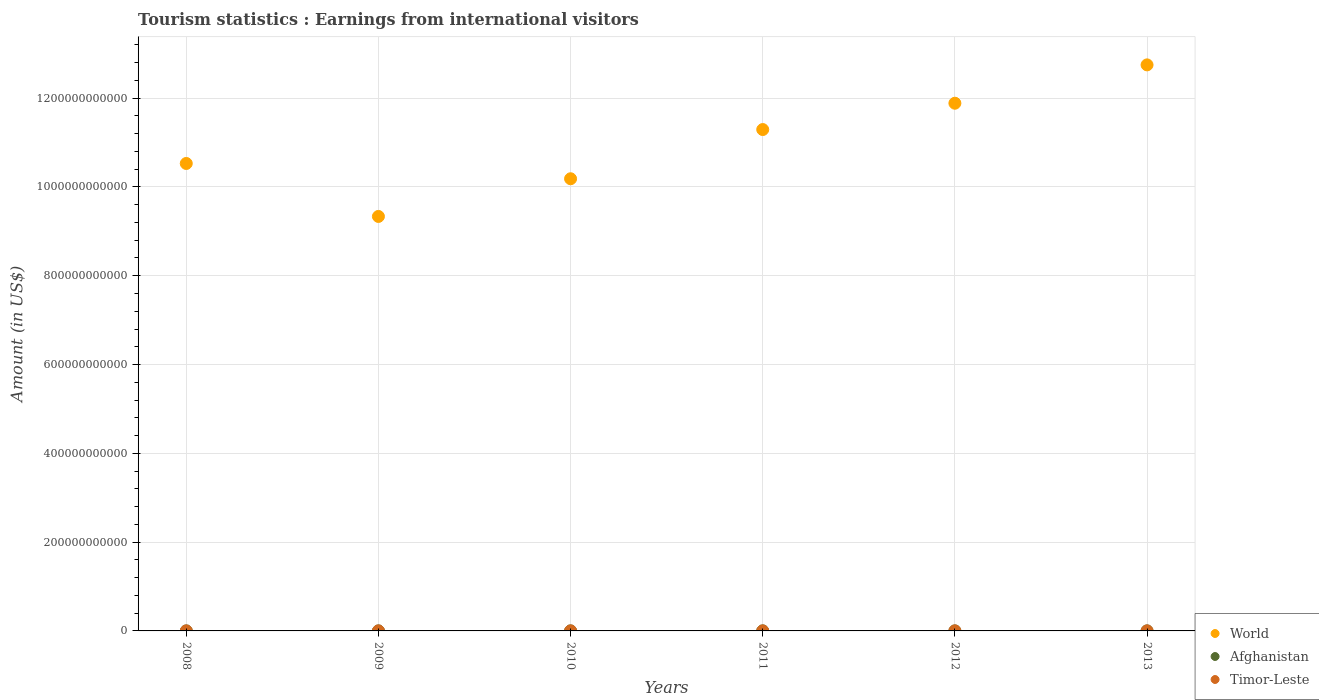How many different coloured dotlines are there?
Provide a short and direct response. 3. Is the number of dotlines equal to the number of legend labels?
Keep it short and to the point. Yes. What is the earnings from international visitors in World in 2009?
Ensure brevity in your answer.  9.34e+11. Across all years, what is the maximum earnings from international visitors in Afghanistan?
Your answer should be compact. 1.27e+08. Across all years, what is the minimum earnings from international visitors in Afghanistan?
Offer a terse response. 5.80e+07. In which year was the earnings from international visitors in World minimum?
Provide a short and direct response. 2009. What is the total earnings from international visitors in Timor-Leste in the graph?
Provide a succinct answer. 3.99e+08. What is the difference between the earnings from international visitors in World in 2008 and that in 2009?
Offer a very short reply. 1.19e+11. What is the difference between the earnings from international visitors in Afghanistan in 2011 and the earnings from international visitors in Timor-Leste in 2013?
Give a very brief answer. 7.00e+07. What is the average earnings from international visitors in World per year?
Keep it short and to the point. 1.10e+12. In the year 2009, what is the difference between the earnings from international visitors in World and earnings from international visitors in Timor-Leste?
Keep it short and to the point. 9.33e+11. What is the ratio of the earnings from international visitors in World in 2011 to that in 2012?
Your answer should be compact. 0.95. Is the earnings from international visitors in Timor-Leste in 2008 less than that in 2013?
Your answer should be compact. Yes. What is the difference between the highest and the second highest earnings from international visitors in Timor-Leste?
Provide a short and direct response. 2.30e+07. What is the difference between the highest and the lowest earnings from international visitors in Timor-Leste?
Provide a succinct answer. 4.10e+07. In how many years, is the earnings from international visitors in World greater than the average earnings from international visitors in World taken over all years?
Your answer should be compact. 3. Is the sum of the earnings from international visitors in World in 2009 and 2013 greater than the maximum earnings from international visitors in Timor-Leste across all years?
Offer a terse response. Yes. Is the earnings from international visitors in Timor-Leste strictly greater than the earnings from international visitors in Afghanistan over the years?
Give a very brief answer. No. How many years are there in the graph?
Offer a terse response. 6. What is the difference between two consecutive major ticks on the Y-axis?
Offer a very short reply. 2.00e+11. Does the graph contain any zero values?
Offer a very short reply. No. How many legend labels are there?
Ensure brevity in your answer.  3. How are the legend labels stacked?
Ensure brevity in your answer.  Vertical. What is the title of the graph?
Your answer should be very brief. Tourism statistics : Earnings from international visitors. Does "Maldives" appear as one of the legend labels in the graph?
Your answer should be very brief. No. What is the label or title of the Y-axis?
Your response must be concise. Amount (in US$). What is the Amount (in US$) of World in 2008?
Ensure brevity in your answer.  1.05e+12. What is the Amount (in US$) in Afghanistan in 2008?
Make the answer very short. 5.80e+07. What is the Amount (in US$) in Timor-Leste in 2008?
Keep it short and to the point. 5.10e+07. What is the Amount (in US$) in World in 2009?
Provide a succinct answer. 9.34e+11. What is the Amount (in US$) in Afghanistan in 2009?
Your answer should be very brief. 6.10e+07. What is the Amount (in US$) of Timor-Leste in 2009?
Provide a succinct answer. 6.90e+07. What is the Amount (in US$) in World in 2010?
Make the answer very short. 1.02e+12. What is the Amount (in US$) in Afghanistan in 2010?
Your answer should be compact. 8.60e+07. What is the Amount (in US$) of Timor-Leste in 2010?
Give a very brief answer. 6.80e+07. What is the Amount (in US$) of World in 2011?
Your answer should be very brief. 1.13e+12. What is the Amount (in US$) of Afghanistan in 2011?
Your answer should be very brief. 1.27e+08. What is the Amount (in US$) of Timor-Leste in 2011?
Your answer should be compact. 6.20e+07. What is the Amount (in US$) of World in 2012?
Provide a short and direct response. 1.19e+12. What is the Amount (in US$) in Afghanistan in 2012?
Give a very brief answer. 8.00e+07. What is the Amount (in US$) in Timor-Leste in 2012?
Your answer should be compact. 9.20e+07. What is the Amount (in US$) of World in 2013?
Keep it short and to the point. 1.27e+12. What is the Amount (in US$) in Afghanistan in 2013?
Give a very brief answer. 1.00e+08. What is the Amount (in US$) of Timor-Leste in 2013?
Ensure brevity in your answer.  5.70e+07. Across all years, what is the maximum Amount (in US$) of World?
Your response must be concise. 1.27e+12. Across all years, what is the maximum Amount (in US$) in Afghanistan?
Ensure brevity in your answer.  1.27e+08. Across all years, what is the maximum Amount (in US$) of Timor-Leste?
Ensure brevity in your answer.  9.20e+07. Across all years, what is the minimum Amount (in US$) of World?
Offer a terse response. 9.34e+11. Across all years, what is the minimum Amount (in US$) of Afghanistan?
Provide a short and direct response. 5.80e+07. Across all years, what is the minimum Amount (in US$) of Timor-Leste?
Give a very brief answer. 5.10e+07. What is the total Amount (in US$) in World in the graph?
Provide a short and direct response. 6.60e+12. What is the total Amount (in US$) of Afghanistan in the graph?
Give a very brief answer. 5.12e+08. What is the total Amount (in US$) in Timor-Leste in the graph?
Give a very brief answer. 3.99e+08. What is the difference between the Amount (in US$) in World in 2008 and that in 2009?
Your answer should be very brief. 1.19e+11. What is the difference between the Amount (in US$) in Timor-Leste in 2008 and that in 2009?
Offer a very short reply. -1.80e+07. What is the difference between the Amount (in US$) of World in 2008 and that in 2010?
Make the answer very short. 3.44e+1. What is the difference between the Amount (in US$) of Afghanistan in 2008 and that in 2010?
Keep it short and to the point. -2.80e+07. What is the difference between the Amount (in US$) in Timor-Leste in 2008 and that in 2010?
Your response must be concise. -1.70e+07. What is the difference between the Amount (in US$) in World in 2008 and that in 2011?
Offer a very short reply. -7.64e+1. What is the difference between the Amount (in US$) in Afghanistan in 2008 and that in 2011?
Offer a terse response. -6.90e+07. What is the difference between the Amount (in US$) in Timor-Leste in 2008 and that in 2011?
Offer a terse response. -1.10e+07. What is the difference between the Amount (in US$) in World in 2008 and that in 2012?
Your answer should be compact. -1.36e+11. What is the difference between the Amount (in US$) of Afghanistan in 2008 and that in 2012?
Keep it short and to the point. -2.20e+07. What is the difference between the Amount (in US$) in Timor-Leste in 2008 and that in 2012?
Your answer should be compact. -4.10e+07. What is the difference between the Amount (in US$) of World in 2008 and that in 2013?
Offer a very short reply. -2.22e+11. What is the difference between the Amount (in US$) of Afghanistan in 2008 and that in 2013?
Make the answer very short. -4.20e+07. What is the difference between the Amount (in US$) in Timor-Leste in 2008 and that in 2013?
Provide a short and direct response. -6.00e+06. What is the difference between the Amount (in US$) of World in 2009 and that in 2010?
Your answer should be compact. -8.49e+1. What is the difference between the Amount (in US$) in Afghanistan in 2009 and that in 2010?
Provide a short and direct response. -2.50e+07. What is the difference between the Amount (in US$) in Timor-Leste in 2009 and that in 2010?
Your response must be concise. 1.00e+06. What is the difference between the Amount (in US$) in World in 2009 and that in 2011?
Your answer should be very brief. -1.96e+11. What is the difference between the Amount (in US$) of Afghanistan in 2009 and that in 2011?
Your answer should be compact. -6.60e+07. What is the difference between the Amount (in US$) of Timor-Leste in 2009 and that in 2011?
Ensure brevity in your answer.  7.00e+06. What is the difference between the Amount (in US$) of World in 2009 and that in 2012?
Keep it short and to the point. -2.55e+11. What is the difference between the Amount (in US$) in Afghanistan in 2009 and that in 2012?
Offer a very short reply. -1.90e+07. What is the difference between the Amount (in US$) of Timor-Leste in 2009 and that in 2012?
Your answer should be compact. -2.30e+07. What is the difference between the Amount (in US$) in World in 2009 and that in 2013?
Make the answer very short. -3.41e+11. What is the difference between the Amount (in US$) in Afghanistan in 2009 and that in 2013?
Your answer should be compact. -3.90e+07. What is the difference between the Amount (in US$) in Timor-Leste in 2009 and that in 2013?
Keep it short and to the point. 1.20e+07. What is the difference between the Amount (in US$) of World in 2010 and that in 2011?
Give a very brief answer. -1.11e+11. What is the difference between the Amount (in US$) in Afghanistan in 2010 and that in 2011?
Your answer should be compact. -4.10e+07. What is the difference between the Amount (in US$) of Timor-Leste in 2010 and that in 2011?
Ensure brevity in your answer.  6.00e+06. What is the difference between the Amount (in US$) of World in 2010 and that in 2012?
Your response must be concise. -1.70e+11. What is the difference between the Amount (in US$) in Afghanistan in 2010 and that in 2012?
Your answer should be very brief. 6.00e+06. What is the difference between the Amount (in US$) in Timor-Leste in 2010 and that in 2012?
Provide a succinct answer. -2.40e+07. What is the difference between the Amount (in US$) in World in 2010 and that in 2013?
Offer a very short reply. -2.57e+11. What is the difference between the Amount (in US$) in Afghanistan in 2010 and that in 2013?
Make the answer very short. -1.40e+07. What is the difference between the Amount (in US$) of Timor-Leste in 2010 and that in 2013?
Provide a succinct answer. 1.10e+07. What is the difference between the Amount (in US$) of World in 2011 and that in 2012?
Offer a terse response. -5.93e+1. What is the difference between the Amount (in US$) of Afghanistan in 2011 and that in 2012?
Your answer should be very brief. 4.70e+07. What is the difference between the Amount (in US$) of Timor-Leste in 2011 and that in 2012?
Offer a terse response. -3.00e+07. What is the difference between the Amount (in US$) in World in 2011 and that in 2013?
Give a very brief answer. -1.46e+11. What is the difference between the Amount (in US$) in Afghanistan in 2011 and that in 2013?
Give a very brief answer. 2.70e+07. What is the difference between the Amount (in US$) of Timor-Leste in 2011 and that in 2013?
Offer a terse response. 5.00e+06. What is the difference between the Amount (in US$) of World in 2012 and that in 2013?
Offer a very short reply. -8.64e+1. What is the difference between the Amount (in US$) of Afghanistan in 2012 and that in 2013?
Provide a short and direct response. -2.00e+07. What is the difference between the Amount (in US$) in Timor-Leste in 2012 and that in 2013?
Give a very brief answer. 3.50e+07. What is the difference between the Amount (in US$) of World in 2008 and the Amount (in US$) of Afghanistan in 2009?
Your response must be concise. 1.05e+12. What is the difference between the Amount (in US$) of World in 2008 and the Amount (in US$) of Timor-Leste in 2009?
Your answer should be compact. 1.05e+12. What is the difference between the Amount (in US$) in Afghanistan in 2008 and the Amount (in US$) in Timor-Leste in 2009?
Offer a terse response. -1.10e+07. What is the difference between the Amount (in US$) in World in 2008 and the Amount (in US$) in Afghanistan in 2010?
Ensure brevity in your answer.  1.05e+12. What is the difference between the Amount (in US$) of World in 2008 and the Amount (in US$) of Timor-Leste in 2010?
Your response must be concise. 1.05e+12. What is the difference between the Amount (in US$) of Afghanistan in 2008 and the Amount (in US$) of Timor-Leste in 2010?
Provide a succinct answer. -1.00e+07. What is the difference between the Amount (in US$) of World in 2008 and the Amount (in US$) of Afghanistan in 2011?
Provide a short and direct response. 1.05e+12. What is the difference between the Amount (in US$) of World in 2008 and the Amount (in US$) of Timor-Leste in 2011?
Give a very brief answer. 1.05e+12. What is the difference between the Amount (in US$) in World in 2008 and the Amount (in US$) in Afghanistan in 2012?
Offer a very short reply. 1.05e+12. What is the difference between the Amount (in US$) in World in 2008 and the Amount (in US$) in Timor-Leste in 2012?
Provide a short and direct response. 1.05e+12. What is the difference between the Amount (in US$) of Afghanistan in 2008 and the Amount (in US$) of Timor-Leste in 2012?
Keep it short and to the point. -3.40e+07. What is the difference between the Amount (in US$) of World in 2008 and the Amount (in US$) of Afghanistan in 2013?
Ensure brevity in your answer.  1.05e+12. What is the difference between the Amount (in US$) of World in 2008 and the Amount (in US$) of Timor-Leste in 2013?
Offer a very short reply. 1.05e+12. What is the difference between the Amount (in US$) in Afghanistan in 2008 and the Amount (in US$) in Timor-Leste in 2013?
Provide a short and direct response. 1.00e+06. What is the difference between the Amount (in US$) of World in 2009 and the Amount (in US$) of Afghanistan in 2010?
Offer a terse response. 9.33e+11. What is the difference between the Amount (in US$) of World in 2009 and the Amount (in US$) of Timor-Leste in 2010?
Make the answer very short. 9.33e+11. What is the difference between the Amount (in US$) in Afghanistan in 2009 and the Amount (in US$) in Timor-Leste in 2010?
Keep it short and to the point. -7.00e+06. What is the difference between the Amount (in US$) in World in 2009 and the Amount (in US$) in Afghanistan in 2011?
Your response must be concise. 9.33e+11. What is the difference between the Amount (in US$) of World in 2009 and the Amount (in US$) of Timor-Leste in 2011?
Provide a succinct answer. 9.33e+11. What is the difference between the Amount (in US$) of World in 2009 and the Amount (in US$) of Afghanistan in 2012?
Ensure brevity in your answer.  9.33e+11. What is the difference between the Amount (in US$) of World in 2009 and the Amount (in US$) of Timor-Leste in 2012?
Keep it short and to the point. 9.33e+11. What is the difference between the Amount (in US$) of Afghanistan in 2009 and the Amount (in US$) of Timor-Leste in 2012?
Ensure brevity in your answer.  -3.10e+07. What is the difference between the Amount (in US$) in World in 2009 and the Amount (in US$) in Afghanistan in 2013?
Your answer should be compact. 9.33e+11. What is the difference between the Amount (in US$) of World in 2009 and the Amount (in US$) of Timor-Leste in 2013?
Give a very brief answer. 9.34e+11. What is the difference between the Amount (in US$) of Afghanistan in 2009 and the Amount (in US$) of Timor-Leste in 2013?
Your response must be concise. 4.00e+06. What is the difference between the Amount (in US$) in World in 2010 and the Amount (in US$) in Afghanistan in 2011?
Offer a very short reply. 1.02e+12. What is the difference between the Amount (in US$) in World in 2010 and the Amount (in US$) in Timor-Leste in 2011?
Offer a terse response. 1.02e+12. What is the difference between the Amount (in US$) in Afghanistan in 2010 and the Amount (in US$) in Timor-Leste in 2011?
Provide a short and direct response. 2.40e+07. What is the difference between the Amount (in US$) in World in 2010 and the Amount (in US$) in Afghanistan in 2012?
Make the answer very short. 1.02e+12. What is the difference between the Amount (in US$) in World in 2010 and the Amount (in US$) in Timor-Leste in 2012?
Your response must be concise. 1.02e+12. What is the difference between the Amount (in US$) in Afghanistan in 2010 and the Amount (in US$) in Timor-Leste in 2012?
Your response must be concise. -6.00e+06. What is the difference between the Amount (in US$) of World in 2010 and the Amount (in US$) of Afghanistan in 2013?
Make the answer very short. 1.02e+12. What is the difference between the Amount (in US$) in World in 2010 and the Amount (in US$) in Timor-Leste in 2013?
Offer a terse response. 1.02e+12. What is the difference between the Amount (in US$) of Afghanistan in 2010 and the Amount (in US$) of Timor-Leste in 2013?
Keep it short and to the point. 2.90e+07. What is the difference between the Amount (in US$) of World in 2011 and the Amount (in US$) of Afghanistan in 2012?
Offer a very short reply. 1.13e+12. What is the difference between the Amount (in US$) in World in 2011 and the Amount (in US$) in Timor-Leste in 2012?
Ensure brevity in your answer.  1.13e+12. What is the difference between the Amount (in US$) of Afghanistan in 2011 and the Amount (in US$) of Timor-Leste in 2012?
Provide a short and direct response. 3.50e+07. What is the difference between the Amount (in US$) in World in 2011 and the Amount (in US$) in Afghanistan in 2013?
Provide a short and direct response. 1.13e+12. What is the difference between the Amount (in US$) of World in 2011 and the Amount (in US$) of Timor-Leste in 2013?
Offer a terse response. 1.13e+12. What is the difference between the Amount (in US$) in Afghanistan in 2011 and the Amount (in US$) in Timor-Leste in 2013?
Provide a succinct answer. 7.00e+07. What is the difference between the Amount (in US$) of World in 2012 and the Amount (in US$) of Afghanistan in 2013?
Give a very brief answer. 1.19e+12. What is the difference between the Amount (in US$) in World in 2012 and the Amount (in US$) in Timor-Leste in 2013?
Ensure brevity in your answer.  1.19e+12. What is the difference between the Amount (in US$) in Afghanistan in 2012 and the Amount (in US$) in Timor-Leste in 2013?
Provide a succinct answer. 2.30e+07. What is the average Amount (in US$) of World per year?
Offer a terse response. 1.10e+12. What is the average Amount (in US$) of Afghanistan per year?
Your answer should be very brief. 8.53e+07. What is the average Amount (in US$) in Timor-Leste per year?
Keep it short and to the point. 6.65e+07. In the year 2008, what is the difference between the Amount (in US$) in World and Amount (in US$) in Afghanistan?
Your answer should be compact. 1.05e+12. In the year 2008, what is the difference between the Amount (in US$) of World and Amount (in US$) of Timor-Leste?
Your answer should be compact. 1.05e+12. In the year 2009, what is the difference between the Amount (in US$) of World and Amount (in US$) of Afghanistan?
Offer a terse response. 9.33e+11. In the year 2009, what is the difference between the Amount (in US$) in World and Amount (in US$) in Timor-Leste?
Your response must be concise. 9.33e+11. In the year 2009, what is the difference between the Amount (in US$) in Afghanistan and Amount (in US$) in Timor-Leste?
Your response must be concise. -8.00e+06. In the year 2010, what is the difference between the Amount (in US$) of World and Amount (in US$) of Afghanistan?
Your answer should be compact. 1.02e+12. In the year 2010, what is the difference between the Amount (in US$) in World and Amount (in US$) in Timor-Leste?
Provide a succinct answer. 1.02e+12. In the year 2010, what is the difference between the Amount (in US$) of Afghanistan and Amount (in US$) of Timor-Leste?
Offer a very short reply. 1.80e+07. In the year 2011, what is the difference between the Amount (in US$) in World and Amount (in US$) in Afghanistan?
Offer a very short reply. 1.13e+12. In the year 2011, what is the difference between the Amount (in US$) in World and Amount (in US$) in Timor-Leste?
Give a very brief answer. 1.13e+12. In the year 2011, what is the difference between the Amount (in US$) in Afghanistan and Amount (in US$) in Timor-Leste?
Your answer should be very brief. 6.50e+07. In the year 2012, what is the difference between the Amount (in US$) in World and Amount (in US$) in Afghanistan?
Offer a terse response. 1.19e+12. In the year 2012, what is the difference between the Amount (in US$) in World and Amount (in US$) in Timor-Leste?
Provide a short and direct response. 1.19e+12. In the year 2012, what is the difference between the Amount (in US$) of Afghanistan and Amount (in US$) of Timor-Leste?
Provide a succinct answer. -1.20e+07. In the year 2013, what is the difference between the Amount (in US$) of World and Amount (in US$) of Afghanistan?
Ensure brevity in your answer.  1.27e+12. In the year 2013, what is the difference between the Amount (in US$) in World and Amount (in US$) in Timor-Leste?
Your answer should be very brief. 1.27e+12. In the year 2013, what is the difference between the Amount (in US$) of Afghanistan and Amount (in US$) of Timor-Leste?
Provide a succinct answer. 4.30e+07. What is the ratio of the Amount (in US$) of World in 2008 to that in 2009?
Keep it short and to the point. 1.13. What is the ratio of the Amount (in US$) in Afghanistan in 2008 to that in 2009?
Ensure brevity in your answer.  0.95. What is the ratio of the Amount (in US$) of Timor-Leste in 2008 to that in 2009?
Your answer should be very brief. 0.74. What is the ratio of the Amount (in US$) in World in 2008 to that in 2010?
Offer a very short reply. 1.03. What is the ratio of the Amount (in US$) in Afghanistan in 2008 to that in 2010?
Your answer should be very brief. 0.67. What is the ratio of the Amount (in US$) in World in 2008 to that in 2011?
Provide a short and direct response. 0.93. What is the ratio of the Amount (in US$) in Afghanistan in 2008 to that in 2011?
Make the answer very short. 0.46. What is the ratio of the Amount (in US$) in Timor-Leste in 2008 to that in 2011?
Make the answer very short. 0.82. What is the ratio of the Amount (in US$) in World in 2008 to that in 2012?
Your answer should be very brief. 0.89. What is the ratio of the Amount (in US$) in Afghanistan in 2008 to that in 2012?
Ensure brevity in your answer.  0.72. What is the ratio of the Amount (in US$) in Timor-Leste in 2008 to that in 2012?
Your answer should be very brief. 0.55. What is the ratio of the Amount (in US$) in World in 2008 to that in 2013?
Give a very brief answer. 0.83. What is the ratio of the Amount (in US$) of Afghanistan in 2008 to that in 2013?
Offer a very short reply. 0.58. What is the ratio of the Amount (in US$) of Timor-Leste in 2008 to that in 2013?
Provide a succinct answer. 0.89. What is the ratio of the Amount (in US$) of Afghanistan in 2009 to that in 2010?
Make the answer very short. 0.71. What is the ratio of the Amount (in US$) of Timor-Leste in 2009 to that in 2010?
Make the answer very short. 1.01. What is the ratio of the Amount (in US$) in World in 2009 to that in 2011?
Offer a very short reply. 0.83. What is the ratio of the Amount (in US$) in Afghanistan in 2009 to that in 2011?
Your response must be concise. 0.48. What is the ratio of the Amount (in US$) of Timor-Leste in 2009 to that in 2011?
Keep it short and to the point. 1.11. What is the ratio of the Amount (in US$) in World in 2009 to that in 2012?
Offer a very short reply. 0.79. What is the ratio of the Amount (in US$) in Afghanistan in 2009 to that in 2012?
Provide a short and direct response. 0.76. What is the ratio of the Amount (in US$) of Timor-Leste in 2009 to that in 2012?
Offer a terse response. 0.75. What is the ratio of the Amount (in US$) of World in 2009 to that in 2013?
Ensure brevity in your answer.  0.73. What is the ratio of the Amount (in US$) in Afghanistan in 2009 to that in 2013?
Keep it short and to the point. 0.61. What is the ratio of the Amount (in US$) of Timor-Leste in 2009 to that in 2013?
Offer a terse response. 1.21. What is the ratio of the Amount (in US$) in World in 2010 to that in 2011?
Ensure brevity in your answer.  0.9. What is the ratio of the Amount (in US$) of Afghanistan in 2010 to that in 2011?
Provide a short and direct response. 0.68. What is the ratio of the Amount (in US$) of Timor-Leste in 2010 to that in 2011?
Offer a very short reply. 1.1. What is the ratio of the Amount (in US$) of World in 2010 to that in 2012?
Your answer should be very brief. 0.86. What is the ratio of the Amount (in US$) of Afghanistan in 2010 to that in 2012?
Give a very brief answer. 1.07. What is the ratio of the Amount (in US$) in Timor-Leste in 2010 to that in 2012?
Your answer should be compact. 0.74. What is the ratio of the Amount (in US$) of World in 2010 to that in 2013?
Make the answer very short. 0.8. What is the ratio of the Amount (in US$) in Afghanistan in 2010 to that in 2013?
Offer a very short reply. 0.86. What is the ratio of the Amount (in US$) of Timor-Leste in 2010 to that in 2013?
Provide a short and direct response. 1.19. What is the ratio of the Amount (in US$) of World in 2011 to that in 2012?
Your answer should be compact. 0.95. What is the ratio of the Amount (in US$) of Afghanistan in 2011 to that in 2012?
Keep it short and to the point. 1.59. What is the ratio of the Amount (in US$) in Timor-Leste in 2011 to that in 2012?
Your answer should be compact. 0.67. What is the ratio of the Amount (in US$) of World in 2011 to that in 2013?
Offer a terse response. 0.89. What is the ratio of the Amount (in US$) of Afghanistan in 2011 to that in 2013?
Your answer should be compact. 1.27. What is the ratio of the Amount (in US$) in Timor-Leste in 2011 to that in 2013?
Your response must be concise. 1.09. What is the ratio of the Amount (in US$) of World in 2012 to that in 2013?
Your answer should be very brief. 0.93. What is the ratio of the Amount (in US$) in Timor-Leste in 2012 to that in 2013?
Your answer should be very brief. 1.61. What is the difference between the highest and the second highest Amount (in US$) of World?
Provide a short and direct response. 8.64e+1. What is the difference between the highest and the second highest Amount (in US$) of Afghanistan?
Offer a terse response. 2.70e+07. What is the difference between the highest and the second highest Amount (in US$) in Timor-Leste?
Make the answer very short. 2.30e+07. What is the difference between the highest and the lowest Amount (in US$) in World?
Give a very brief answer. 3.41e+11. What is the difference between the highest and the lowest Amount (in US$) in Afghanistan?
Your response must be concise. 6.90e+07. What is the difference between the highest and the lowest Amount (in US$) of Timor-Leste?
Provide a short and direct response. 4.10e+07. 